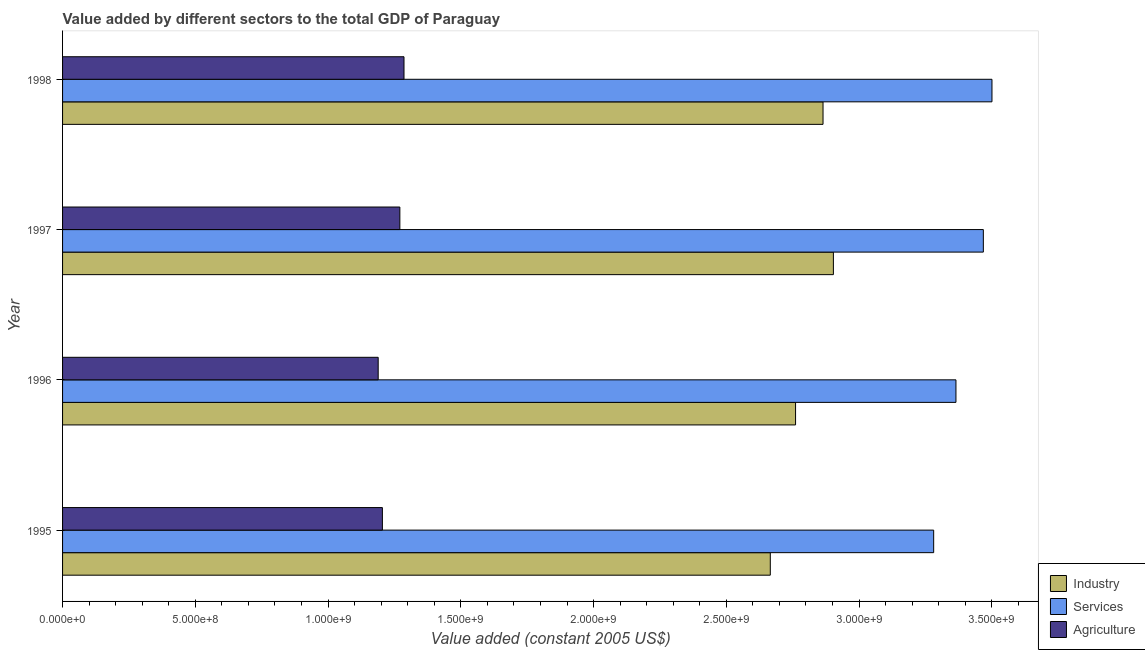How many groups of bars are there?
Keep it short and to the point. 4. Are the number of bars on each tick of the Y-axis equal?
Make the answer very short. Yes. How many bars are there on the 2nd tick from the top?
Ensure brevity in your answer.  3. How many bars are there on the 1st tick from the bottom?
Your response must be concise. 3. What is the label of the 3rd group of bars from the top?
Give a very brief answer. 1996. In how many cases, is the number of bars for a given year not equal to the number of legend labels?
Ensure brevity in your answer.  0. What is the value added by industrial sector in 1997?
Offer a very short reply. 2.90e+09. Across all years, what is the maximum value added by agricultural sector?
Your response must be concise. 1.29e+09. Across all years, what is the minimum value added by agricultural sector?
Offer a very short reply. 1.19e+09. In which year was the value added by industrial sector maximum?
Offer a very short reply. 1997. What is the total value added by agricultural sector in the graph?
Make the answer very short. 4.95e+09. What is the difference between the value added by agricultural sector in 1995 and that in 1997?
Your answer should be compact. -6.58e+07. What is the difference between the value added by agricultural sector in 1995 and the value added by services in 1996?
Your answer should be very brief. -2.16e+09. What is the average value added by agricultural sector per year?
Your answer should be very brief. 1.24e+09. In the year 1996, what is the difference between the value added by industrial sector and value added by agricultural sector?
Provide a succinct answer. 1.57e+09. Is the value added by industrial sector in 1996 less than that in 1998?
Keep it short and to the point. Yes. Is the difference between the value added by agricultural sector in 1996 and 1998 greater than the difference between the value added by services in 1996 and 1998?
Make the answer very short. Yes. What is the difference between the highest and the second highest value added by industrial sector?
Ensure brevity in your answer.  3.90e+07. What is the difference between the highest and the lowest value added by services?
Offer a very short reply. 2.20e+08. In how many years, is the value added by agricultural sector greater than the average value added by agricultural sector taken over all years?
Your answer should be compact. 2. Is the sum of the value added by services in 1995 and 1996 greater than the maximum value added by industrial sector across all years?
Your answer should be very brief. Yes. What does the 2nd bar from the top in 1995 represents?
Offer a very short reply. Services. What does the 2nd bar from the bottom in 1996 represents?
Keep it short and to the point. Services. Is it the case that in every year, the sum of the value added by industrial sector and value added by services is greater than the value added by agricultural sector?
Keep it short and to the point. Yes. How many years are there in the graph?
Ensure brevity in your answer.  4. What is the difference between two consecutive major ticks on the X-axis?
Offer a terse response. 5.00e+08. Are the values on the major ticks of X-axis written in scientific E-notation?
Provide a succinct answer. Yes. Does the graph contain any zero values?
Your answer should be compact. No. Does the graph contain grids?
Keep it short and to the point. No. Where does the legend appear in the graph?
Offer a very short reply. Bottom right. How are the legend labels stacked?
Ensure brevity in your answer.  Vertical. What is the title of the graph?
Your answer should be very brief. Value added by different sectors to the total GDP of Paraguay. Does "Refusal of sex" appear as one of the legend labels in the graph?
Make the answer very short. No. What is the label or title of the X-axis?
Keep it short and to the point. Value added (constant 2005 US$). What is the Value added (constant 2005 US$) of Industry in 1995?
Provide a succinct answer. 2.67e+09. What is the Value added (constant 2005 US$) in Services in 1995?
Provide a succinct answer. 3.28e+09. What is the Value added (constant 2005 US$) of Agriculture in 1995?
Provide a short and direct response. 1.20e+09. What is the Value added (constant 2005 US$) of Industry in 1996?
Make the answer very short. 2.76e+09. What is the Value added (constant 2005 US$) of Services in 1996?
Ensure brevity in your answer.  3.36e+09. What is the Value added (constant 2005 US$) in Agriculture in 1996?
Your answer should be very brief. 1.19e+09. What is the Value added (constant 2005 US$) in Industry in 1997?
Your response must be concise. 2.90e+09. What is the Value added (constant 2005 US$) in Services in 1997?
Give a very brief answer. 3.47e+09. What is the Value added (constant 2005 US$) in Agriculture in 1997?
Ensure brevity in your answer.  1.27e+09. What is the Value added (constant 2005 US$) in Industry in 1998?
Give a very brief answer. 2.86e+09. What is the Value added (constant 2005 US$) in Services in 1998?
Ensure brevity in your answer.  3.50e+09. What is the Value added (constant 2005 US$) of Agriculture in 1998?
Make the answer very short. 1.29e+09. Across all years, what is the maximum Value added (constant 2005 US$) in Industry?
Provide a short and direct response. 2.90e+09. Across all years, what is the maximum Value added (constant 2005 US$) of Services?
Offer a very short reply. 3.50e+09. Across all years, what is the maximum Value added (constant 2005 US$) of Agriculture?
Provide a short and direct response. 1.29e+09. Across all years, what is the minimum Value added (constant 2005 US$) of Industry?
Keep it short and to the point. 2.67e+09. Across all years, what is the minimum Value added (constant 2005 US$) of Services?
Give a very brief answer. 3.28e+09. Across all years, what is the minimum Value added (constant 2005 US$) of Agriculture?
Provide a succinct answer. 1.19e+09. What is the total Value added (constant 2005 US$) of Industry in the graph?
Offer a very short reply. 1.12e+1. What is the total Value added (constant 2005 US$) of Services in the graph?
Provide a short and direct response. 1.36e+1. What is the total Value added (constant 2005 US$) of Agriculture in the graph?
Your response must be concise. 4.95e+09. What is the difference between the Value added (constant 2005 US$) in Industry in 1995 and that in 1996?
Your answer should be compact. -9.51e+07. What is the difference between the Value added (constant 2005 US$) of Services in 1995 and that in 1996?
Provide a succinct answer. -8.40e+07. What is the difference between the Value added (constant 2005 US$) of Agriculture in 1995 and that in 1996?
Offer a very short reply. 1.58e+07. What is the difference between the Value added (constant 2005 US$) in Industry in 1995 and that in 1997?
Ensure brevity in your answer.  -2.38e+08. What is the difference between the Value added (constant 2005 US$) of Services in 1995 and that in 1997?
Your answer should be compact. -1.87e+08. What is the difference between the Value added (constant 2005 US$) of Agriculture in 1995 and that in 1997?
Provide a short and direct response. -6.58e+07. What is the difference between the Value added (constant 2005 US$) of Industry in 1995 and that in 1998?
Ensure brevity in your answer.  -1.99e+08. What is the difference between the Value added (constant 2005 US$) in Services in 1995 and that in 1998?
Your answer should be compact. -2.20e+08. What is the difference between the Value added (constant 2005 US$) in Agriculture in 1995 and that in 1998?
Offer a terse response. -8.14e+07. What is the difference between the Value added (constant 2005 US$) in Industry in 1996 and that in 1997?
Keep it short and to the point. -1.43e+08. What is the difference between the Value added (constant 2005 US$) of Services in 1996 and that in 1997?
Your answer should be very brief. -1.03e+08. What is the difference between the Value added (constant 2005 US$) of Agriculture in 1996 and that in 1997?
Offer a terse response. -8.16e+07. What is the difference between the Value added (constant 2005 US$) in Industry in 1996 and that in 1998?
Make the answer very short. -1.03e+08. What is the difference between the Value added (constant 2005 US$) of Services in 1996 and that in 1998?
Your response must be concise. -1.36e+08. What is the difference between the Value added (constant 2005 US$) of Agriculture in 1996 and that in 1998?
Your answer should be very brief. -9.72e+07. What is the difference between the Value added (constant 2005 US$) in Industry in 1997 and that in 1998?
Keep it short and to the point. 3.90e+07. What is the difference between the Value added (constant 2005 US$) of Services in 1997 and that in 1998?
Provide a short and direct response. -3.25e+07. What is the difference between the Value added (constant 2005 US$) in Agriculture in 1997 and that in 1998?
Give a very brief answer. -1.56e+07. What is the difference between the Value added (constant 2005 US$) in Industry in 1995 and the Value added (constant 2005 US$) in Services in 1996?
Make the answer very short. -6.99e+08. What is the difference between the Value added (constant 2005 US$) of Industry in 1995 and the Value added (constant 2005 US$) of Agriculture in 1996?
Make the answer very short. 1.48e+09. What is the difference between the Value added (constant 2005 US$) in Services in 1995 and the Value added (constant 2005 US$) in Agriculture in 1996?
Make the answer very short. 2.09e+09. What is the difference between the Value added (constant 2005 US$) of Industry in 1995 and the Value added (constant 2005 US$) of Services in 1997?
Give a very brief answer. -8.02e+08. What is the difference between the Value added (constant 2005 US$) in Industry in 1995 and the Value added (constant 2005 US$) in Agriculture in 1997?
Offer a terse response. 1.40e+09. What is the difference between the Value added (constant 2005 US$) of Services in 1995 and the Value added (constant 2005 US$) of Agriculture in 1997?
Give a very brief answer. 2.01e+09. What is the difference between the Value added (constant 2005 US$) in Industry in 1995 and the Value added (constant 2005 US$) in Services in 1998?
Your answer should be very brief. -8.35e+08. What is the difference between the Value added (constant 2005 US$) of Industry in 1995 and the Value added (constant 2005 US$) of Agriculture in 1998?
Make the answer very short. 1.38e+09. What is the difference between the Value added (constant 2005 US$) in Services in 1995 and the Value added (constant 2005 US$) in Agriculture in 1998?
Ensure brevity in your answer.  1.99e+09. What is the difference between the Value added (constant 2005 US$) of Industry in 1996 and the Value added (constant 2005 US$) of Services in 1997?
Offer a very short reply. -7.07e+08. What is the difference between the Value added (constant 2005 US$) in Industry in 1996 and the Value added (constant 2005 US$) in Agriculture in 1997?
Your answer should be compact. 1.49e+09. What is the difference between the Value added (constant 2005 US$) in Services in 1996 and the Value added (constant 2005 US$) in Agriculture in 1997?
Offer a terse response. 2.09e+09. What is the difference between the Value added (constant 2005 US$) of Industry in 1996 and the Value added (constant 2005 US$) of Services in 1998?
Offer a terse response. -7.40e+08. What is the difference between the Value added (constant 2005 US$) in Industry in 1996 and the Value added (constant 2005 US$) in Agriculture in 1998?
Offer a very short reply. 1.47e+09. What is the difference between the Value added (constant 2005 US$) of Services in 1996 and the Value added (constant 2005 US$) of Agriculture in 1998?
Offer a terse response. 2.08e+09. What is the difference between the Value added (constant 2005 US$) in Industry in 1997 and the Value added (constant 2005 US$) in Services in 1998?
Offer a terse response. -5.97e+08. What is the difference between the Value added (constant 2005 US$) in Industry in 1997 and the Value added (constant 2005 US$) in Agriculture in 1998?
Make the answer very short. 1.62e+09. What is the difference between the Value added (constant 2005 US$) in Services in 1997 and the Value added (constant 2005 US$) in Agriculture in 1998?
Keep it short and to the point. 2.18e+09. What is the average Value added (constant 2005 US$) of Industry per year?
Ensure brevity in your answer.  2.80e+09. What is the average Value added (constant 2005 US$) in Services per year?
Offer a very short reply. 3.40e+09. What is the average Value added (constant 2005 US$) of Agriculture per year?
Offer a very short reply. 1.24e+09. In the year 1995, what is the difference between the Value added (constant 2005 US$) in Industry and Value added (constant 2005 US$) in Services?
Keep it short and to the point. -6.15e+08. In the year 1995, what is the difference between the Value added (constant 2005 US$) in Industry and Value added (constant 2005 US$) in Agriculture?
Keep it short and to the point. 1.46e+09. In the year 1995, what is the difference between the Value added (constant 2005 US$) in Services and Value added (constant 2005 US$) in Agriculture?
Your answer should be compact. 2.08e+09. In the year 1996, what is the difference between the Value added (constant 2005 US$) in Industry and Value added (constant 2005 US$) in Services?
Your answer should be very brief. -6.04e+08. In the year 1996, what is the difference between the Value added (constant 2005 US$) in Industry and Value added (constant 2005 US$) in Agriculture?
Your answer should be very brief. 1.57e+09. In the year 1996, what is the difference between the Value added (constant 2005 US$) of Services and Value added (constant 2005 US$) of Agriculture?
Give a very brief answer. 2.18e+09. In the year 1997, what is the difference between the Value added (constant 2005 US$) in Industry and Value added (constant 2005 US$) in Services?
Offer a very short reply. -5.65e+08. In the year 1997, what is the difference between the Value added (constant 2005 US$) of Industry and Value added (constant 2005 US$) of Agriculture?
Your answer should be very brief. 1.63e+09. In the year 1997, what is the difference between the Value added (constant 2005 US$) of Services and Value added (constant 2005 US$) of Agriculture?
Provide a succinct answer. 2.20e+09. In the year 1998, what is the difference between the Value added (constant 2005 US$) of Industry and Value added (constant 2005 US$) of Services?
Offer a terse response. -6.36e+08. In the year 1998, what is the difference between the Value added (constant 2005 US$) in Industry and Value added (constant 2005 US$) in Agriculture?
Provide a succinct answer. 1.58e+09. In the year 1998, what is the difference between the Value added (constant 2005 US$) of Services and Value added (constant 2005 US$) of Agriculture?
Provide a succinct answer. 2.21e+09. What is the ratio of the Value added (constant 2005 US$) in Industry in 1995 to that in 1996?
Your response must be concise. 0.97. What is the ratio of the Value added (constant 2005 US$) in Services in 1995 to that in 1996?
Provide a short and direct response. 0.97. What is the ratio of the Value added (constant 2005 US$) of Agriculture in 1995 to that in 1996?
Your response must be concise. 1.01. What is the ratio of the Value added (constant 2005 US$) of Industry in 1995 to that in 1997?
Your answer should be very brief. 0.92. What is the ratio of the Value added (constant 2005 US$) of Services in 1995 to that in 1997?
Provide a short and direct response. 0.95. What is the ratio of the Value added (constant 2005 US$) of Agriculture in 1995 to that in 1997?
Give a very brief answer. 0.95. What is the ratio of the Value added (constant 2005 US$) of Industry in 1995 to that in 1998?
Keep it short and to the point. 0.93. What is the ratio of the Value added (constant 2005 US$) in Services in 1995 to that in 1998?
Offer a terse response. 0.94. What is the ratio of the Value added (constant 2005 US$) in Agriculture in 1995 to that in 1998?
Your answer should be compact. 0.94. What is the ratio of the Value added (constant 2005 US$) in Industry in 1996 to that in 1997?
Give a very brief answer. 0.95. What is the ratio of the Value added (constant 2005 US$) in Services in 1996 to that in 1997?
Offer a terse response. 0.97. What is the ratio of the Value added (constant 2005 US$) of Agriculture in 1996 to that in 1997?
Offer a very short reply. 0.94. What is the ratio of the Value added (constant 2005 US$) of Industry in 1996 to that in 1998?
Make the answer very short. 0.96. What is the ratio of the Value added (constant 2005 US$) of Services in 1996 to that in 1998?
Your answer should be very brief. 0.96. What is the ratio of the Value added (constant 2005 US$) of Agriculture in 1996 to that in 1998?
Your answer should be very brief. 0.92. What is the ratio of the Value added (constant 2005 US$) of Industry in 1997 to that in 1998?
Offer a terse response. 1.01. What is the ratio of the Value added (constant 2005 US$) in Services in 1997 to that in 1998?
Ensure brevity in your answer.  0.99. What is the ratio of the Value added (constant 2005 US$) in Agriculture in 1997 to that in 1998?
Ensure brevity in your answer.  0.99. What is the difference between the highest and the second highest Value added (constant 2005 US$) in Industry?
Make the answer very short. 3.90e+07. What is the difference between the highest and the second highest Value added (constant 2005 US$) of Services?
Provide a short and direct response. 3.25e+07. What is the difference between the highest and the second highest Value added (constant 2005 US$) of Agriculture?
Ensure brevity in your answer.  1.56e+07. What is the difference between the highest and the lowest Value added (constant 2005 US$) of Industry?
Give a very brief answer. 2.38e+08. What is the difference between the highest and the lowest Value added (constant 2005 US$) in Services?
Your answer should be very brief. 2.20e+08. What is the difference between the highest and the lowest Value added (constant 2005 US$) of Agriculture?
Offer a terse response. 9.72e+07. 